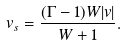<formula> <loc_0><loc_0><loc_500><loc_500>v _ { s } = \frac { ( \Gamma - 1 ) W | v | } { W + 1 } .</formula> 